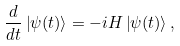Convert formula to latex. <formula><loc_0><loc_0><loc_500><loc_500>\frac { d } { d t } \left | \psi ( t ) \right \rangle = - i H \left | \psi ( t ) \right \rangle ,</formula> 